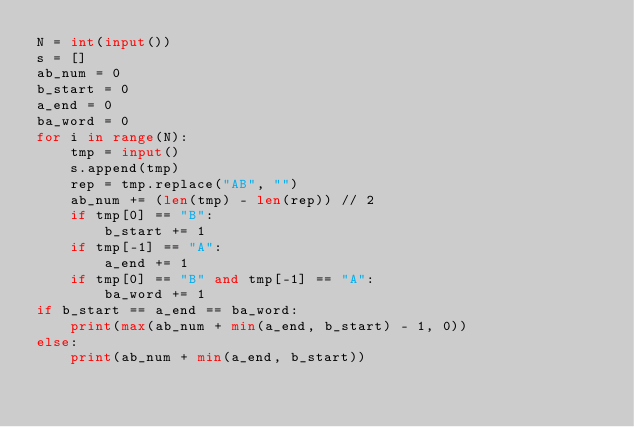<code> <loc_0><loc_0><loc_500><loc_500><_Python_>N = int(input())
s = []
ab_num = 0
b_start = 0
a_end = 0
ba_word = 0
for i in range(N):
    tmp = input()
    s.append(tmp)
    rep = tmp.replace("AB", "")
    ab_num += (len(tmp) - len(rep)) // 2
    if tmp[0] == "B":
        b_start += 1
    if tmp[-1] == "A":
        a_end += 1
    if tmp[0] == "B" and tmp[-1] == "A":
        ba_word += 1
if b_start == a_end == ba_word:
    print(max(ab_num + min(a_end, b_start) - 1, 0))
else:
    print(ab_num + min(a_end, b_start))</code> 